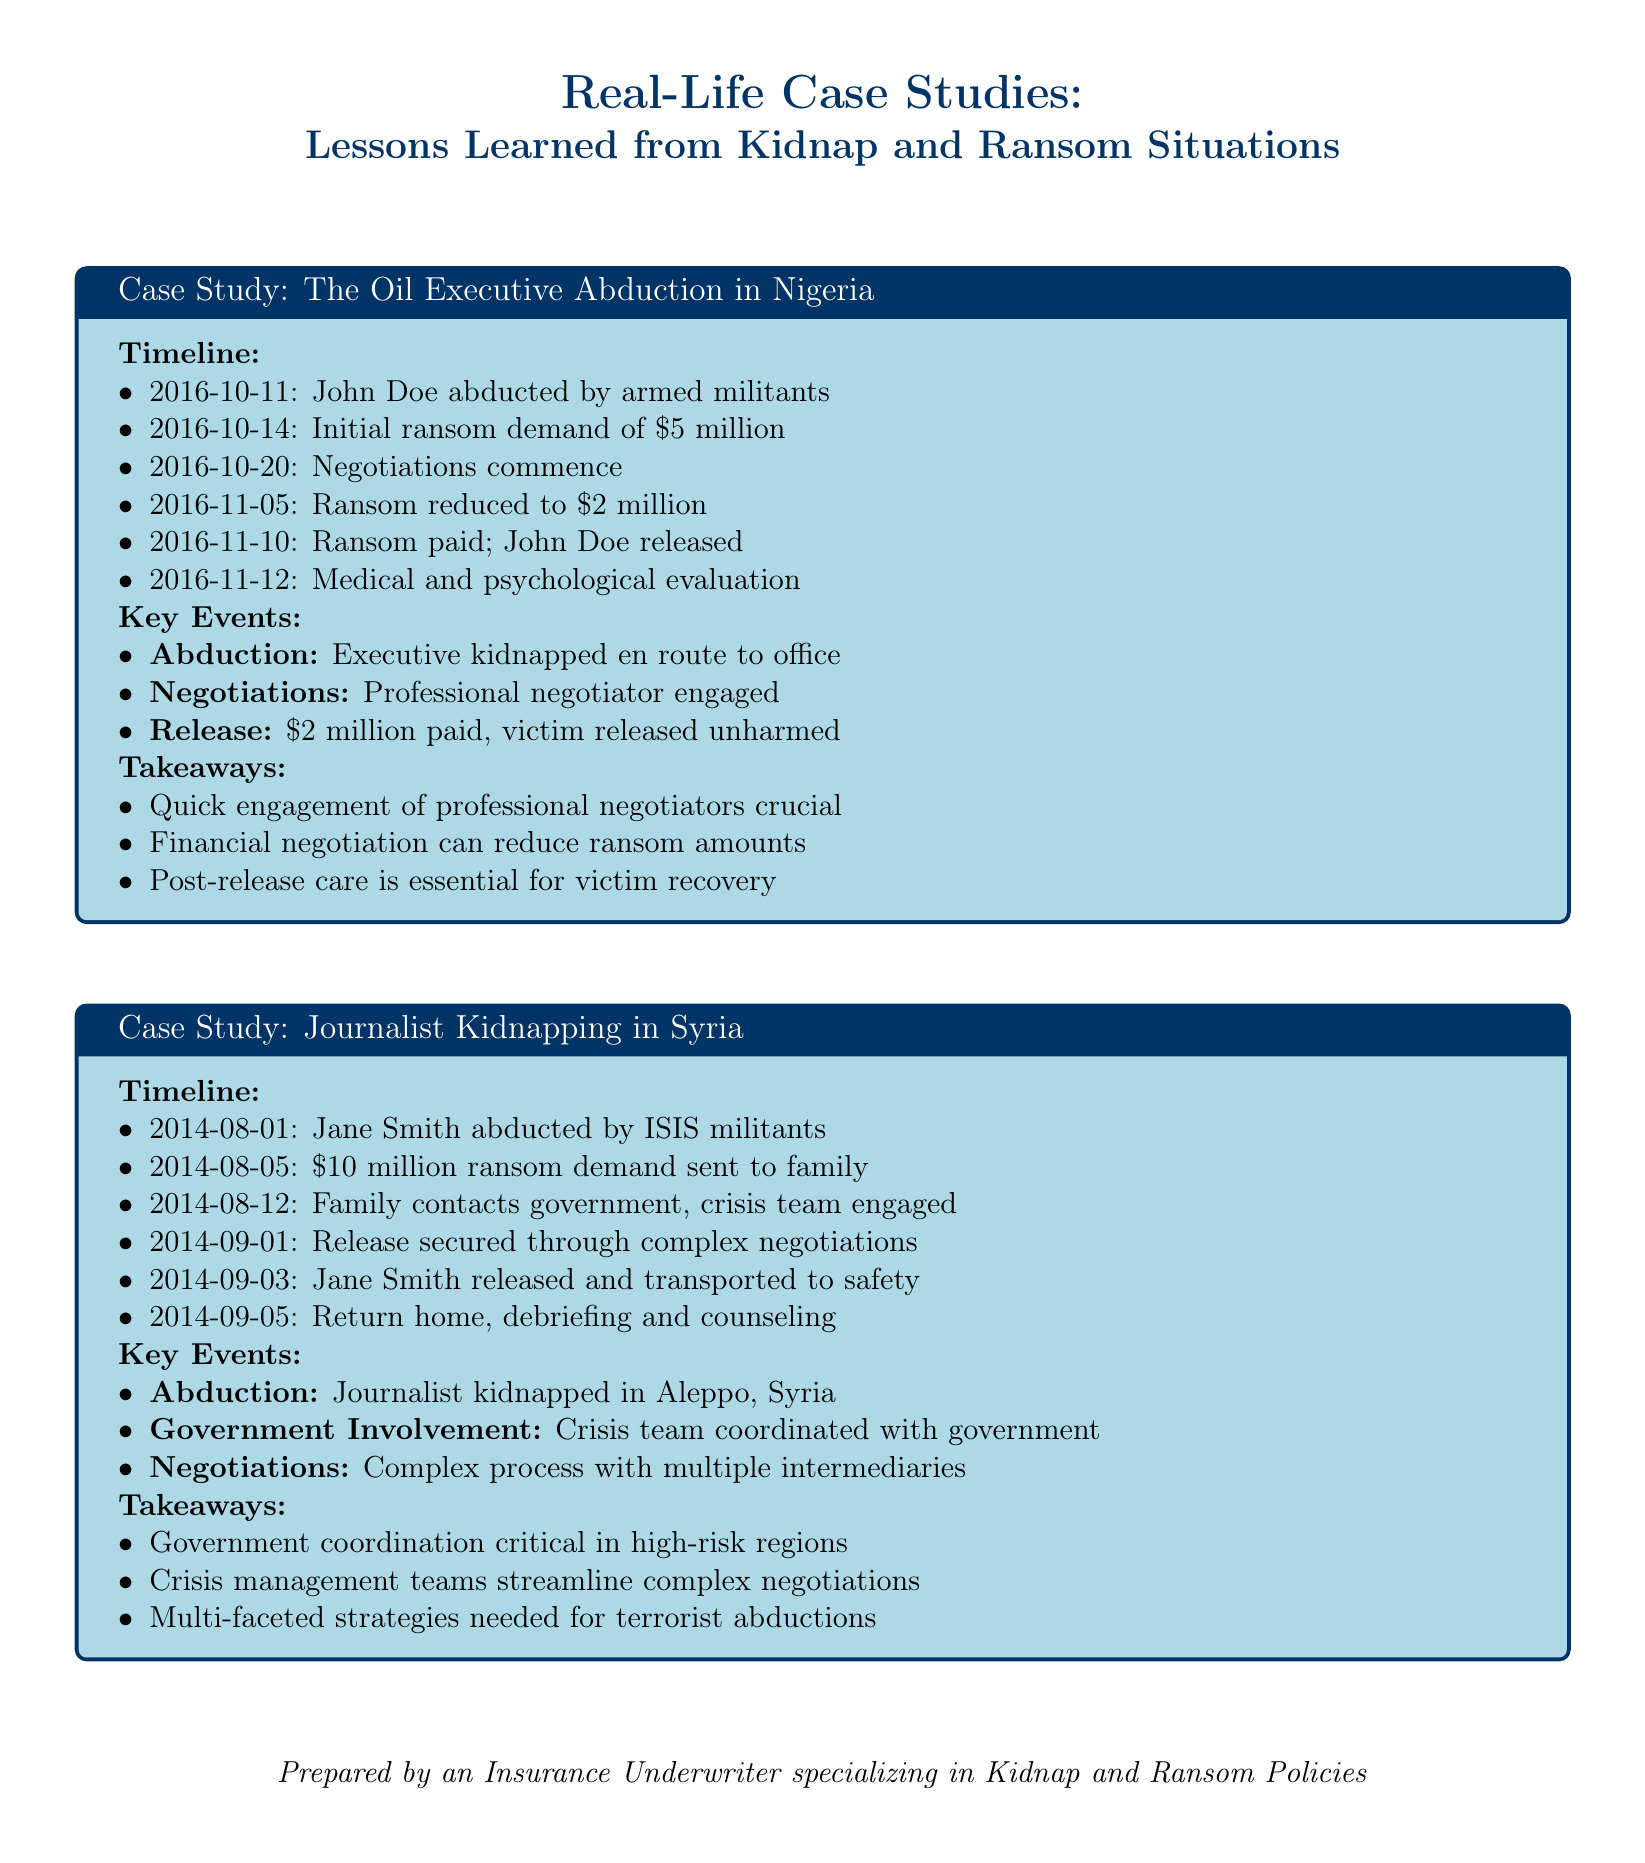What year did the Oil Executive Abduction occur? The abduction of the oil executive took place in October 2016.
Answer: 2016 What was the initial ransom demand in the Oil Executive Abduction case? The initial ransom demand was $5 million.
Answer: $5 million How long was Jane Smith held before her release? Jane Smith was abducted on August 1, 2014, and released on September 3, 2014, which is 33 days.
Answer: 33 days Who was involved in the negotiation of John Doe's release? A professional negotiator was engaged for the negotiations.
Answer: Professional negotiator What critical action did the family take in Jane Smith's case? The family contacted the government and engaged a crisis team.
Answer: Contacted government What is a crucial takeaway from the Oil Executive Abduction case? Quick engagement of professional negotiators is crucial.
Answer: Quick engagement of professional negotiators How did the government assist in the Journalist Kidnapping case? The government coordinated with a crisis team.
Answer: Coordinated with government What is highlighted as essential for victim recovery post-abduction? Post-release care is essential for victim recovery.
Answer: Post-release care What was the final ransom amount paid for John Doe? The final ransom paid was $2 million.
Answer: $2 million 